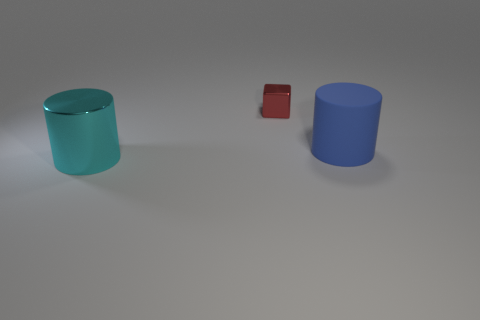Add 3 large cyan cylinders. How many objects exist? 6 Subtract 1 cylinders. How many cylinders are left? 1 Subtract all blocks. How many objects are left? 2 Subtract all large cyan metal cylinders. Subtract all tiny red things. How many objects are left? 1 Add 1 red metal things. How many red metal things are left? 2 Add 2 small yellow shiny blocks. How many small yellow shiny blocks exist? 2 Subtract 0 purple spheres. How many objects are left? 3 Subtract all brown cubes. Subtract all blue spheres. How many cubes are left? 1 